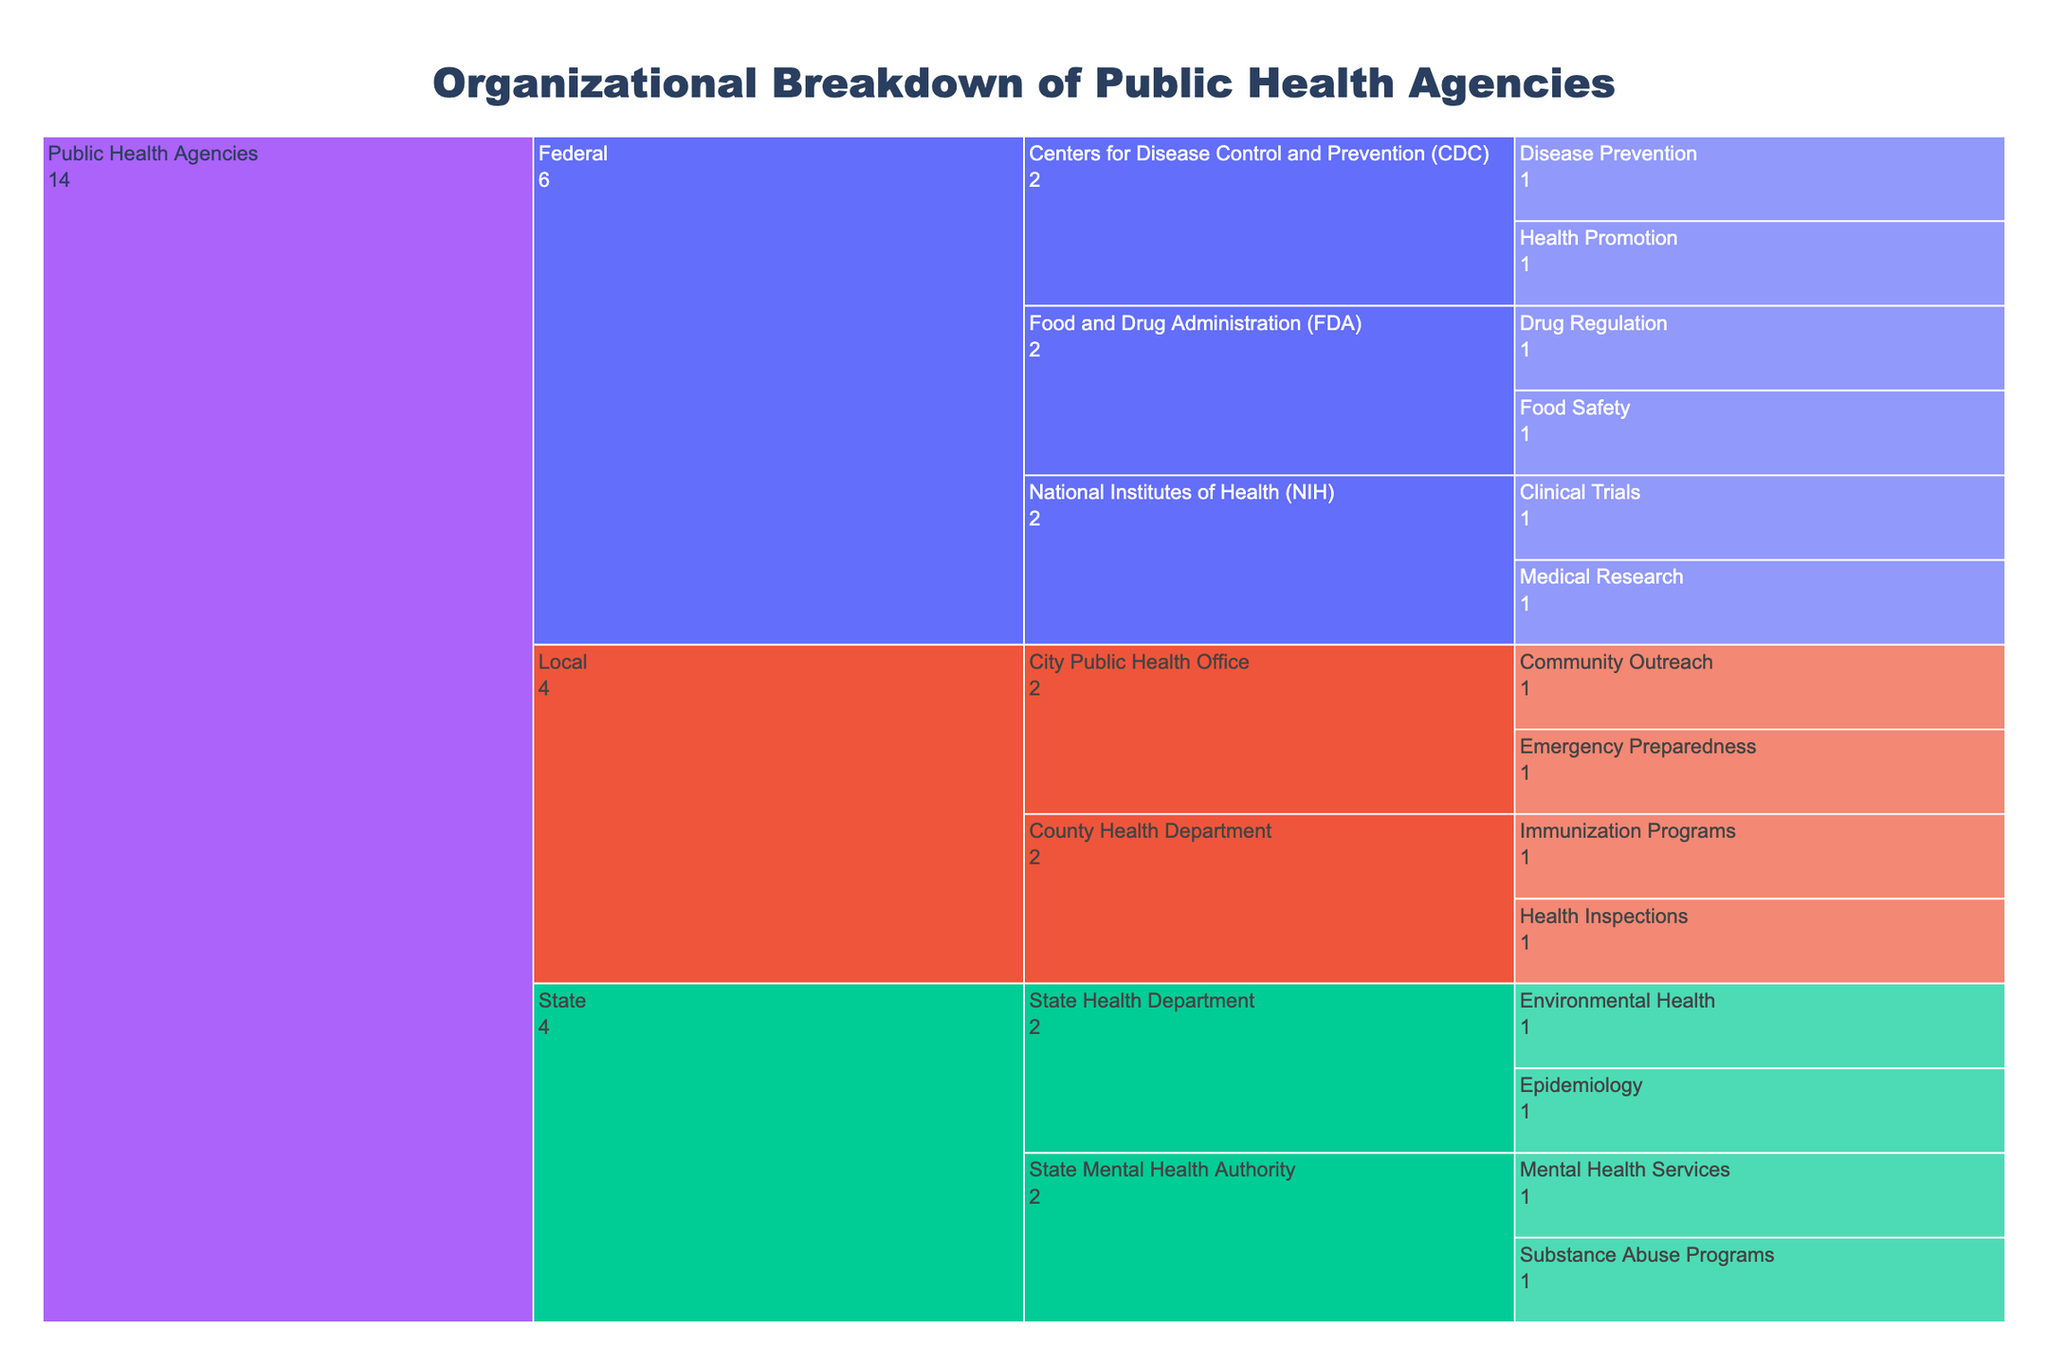what is the title of the figure? The title can be identified from the text at the top of the chart indicating what the chart represents.
Answer: Organizational Breakdown of Public Health Agencies How many local public health agencies are listed in the chart? Count all the leaf nodes under the Local root node. There are County Health Department (Immunization Programs, Health Inspections) and City Public Health Office (Community Outreach, Emergency Preparedness).
Answer: 2 Which federal agency is responsible for disease prevention? Identify the Federal level and then find the appropriate child nodes. Disease Prevention falls under the Centers for Disease Control and Prevention (CDC).
Answer: CDC Compare the number of responsibilities of CDC and FDA. Which one has more? Count the responsibilities (leaves) under CDC and FDA. CDC has 2 (Disease Prevention, Health Promotion), and FDA has 2 (Food Safety, Drug Regulation). They are equal.
Answer: They are equal Which state agency oversees mental health services? Under the State node, find the agency related to mental health. The State Mental Health Authority is responsible for Mental Health Services.
Answer: State Mental Health Authority Total how many activities are listed across all federal public health agencies? Count all the leaf nodes under the Federal root. There are 6 activities in total: CDC (2), FDA (2), NIH (2).
Answer: 6 What are the responsibilities of the National Institutes of Health (NIH)? Look under the NIH node to list its tasks. NIH handles Medical Research and Clinical Trials.
Answer: Medical Research, Clinical Trials Which level has the most diverse set of agencies, Federal, State, or Local? Count the number of different agencies/entities at each level. Federal and State each have 3, and Local has 2. Federal and State are tied for most diverse.
Answer: Federal and State Is the number of public health activities managed at the state level more than at the federal level? Count the total leaf nodes under State and Federal. State has 4 (2 for State Health Department, 2 for State Mental Health Authority), Federal has 6. So, the Federal level has more.
Answer: No Which federal agency focuses on regulating drugs? Find the agency under the Federal node that has “Drug Regulation” as a responsibility. This is the Food and Drug Administration (FDA).
Answer: FDA 